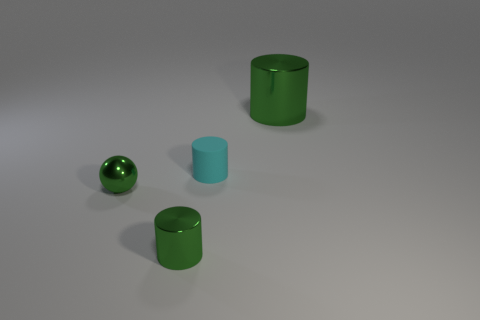Subtract all brown balls. Subtract all green blocks. How many balls are left? 1 Add 3 tiny metal cylinders. How many objects exist? 7 Subtract all balls. How many objects are left? 3 Add 2 cyan rubber things. How many cyan rubber things are left? 3 Add 2 large cyan things. How many large cyan things exist? 2 Subtract 0 cyan cubes. How many objects are left? 4 Subtract all big green cylinders. Subtract all large gray blocks. How many objects are left? 3 